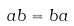<formula> <loc_0><loc_0><loc_500><loc_500>a b = b a</formula> 